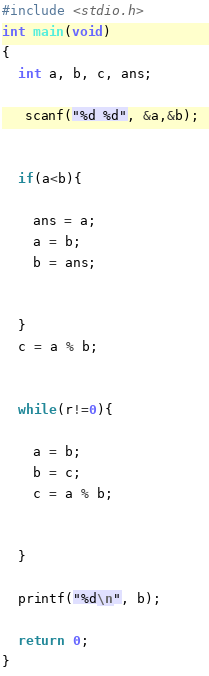<code> <loc_0><loc_0><loc_500><loc_500><_C_>
#include <stdio.h> 
int main(void) 
{ 
  int a, b, c, ans; 

   scanf("%d %d", &a,&b); 


  if(a<b){ 

    ans = a; 
    a = b; 
    b = ans; 


  } 
  c = a % b; 


  while(r!=0){ 

    a = b; 
    b = c; 
    c = a % b; 


  } 

  printf("%d\n", b); 

  return 0; 
} </code> 